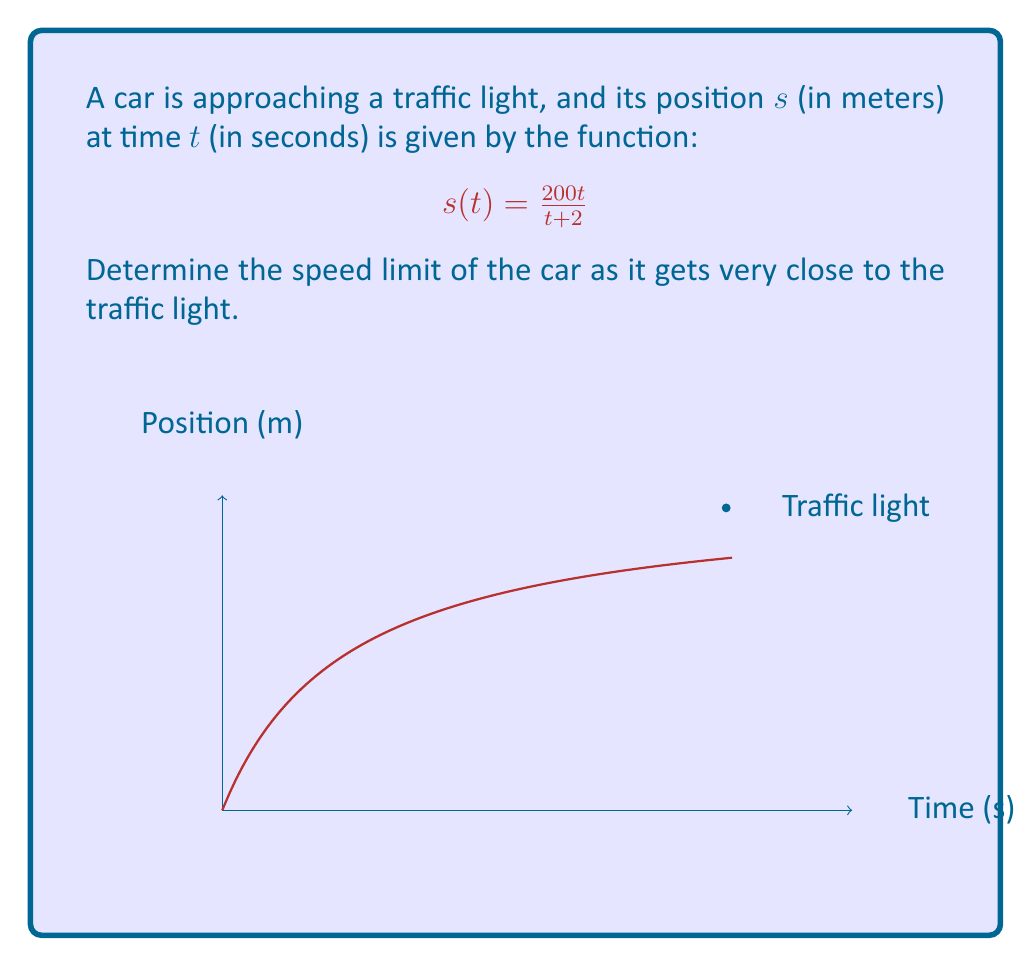Help me with this question. To find the speed limit as the car approaches the traffic light, we need to calculate the limit of the car's velocity as time approaches infinity. Here's how we can do this step-by-step:

1) First, we need to find the velocity function. Velocity is the derivative of position with respect to time:

   $$v(t) = \frac{d}{dt}s(t) = \frac{d}{dt}\left(\frac{200t}{t + 2}\right)$$

2) Using the quotient rule, we get:

   $$v(t) = \frac{200(t+2) - 200t}{(t+2)^2} = \frac{400}{(t+2)^2}$$

3) Now, we need to find the limit of this velocity function as $t$ approaches infinity:

   $$\lim_{t \to \infty} v(t) = \lim_{t \to \infty} \frac{400}{(t+2)^2}$$

4) As $t$ approaches infinity, the denominator $(t+2)^2$ grows much faster than the numerator 400. Therefore:

   $$\lim_{t \to \infty} \frac{400}{(t+2)^2} = 0$$

5) This means that as the car gets very close to the traffic light, its speed approaches 0 m/s.
Answer: 0 m/s 